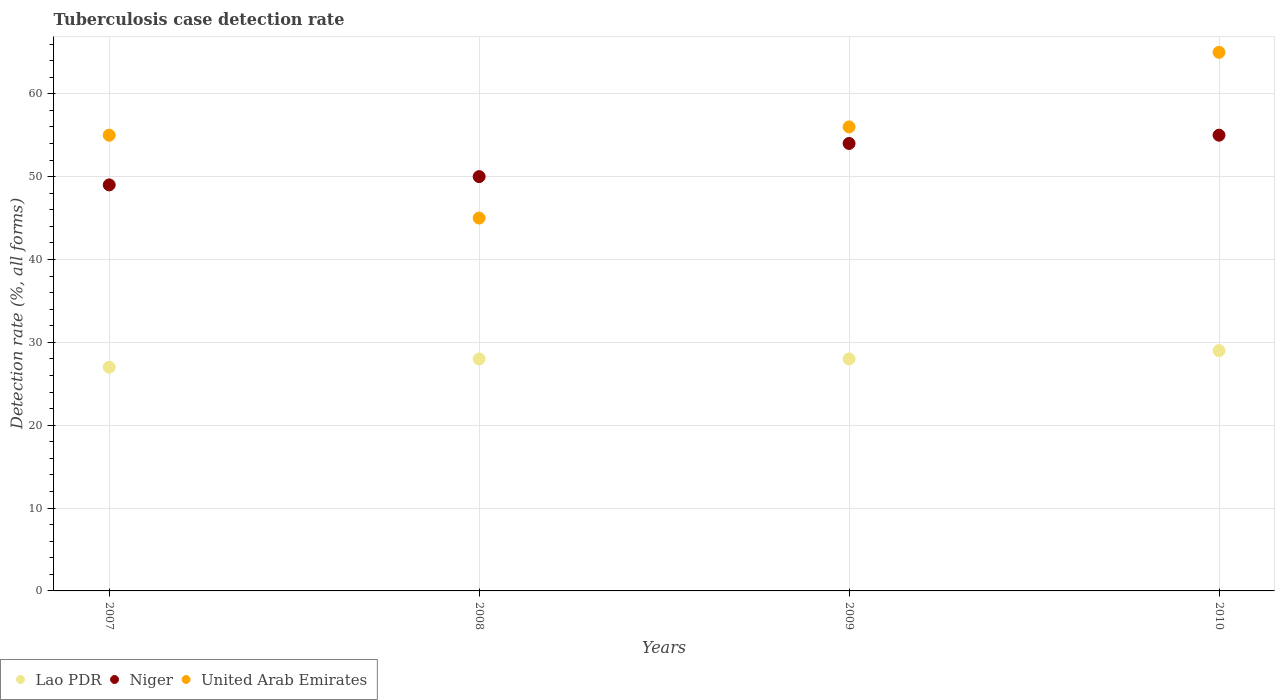What is the tuberculosis case detection rate in in Lao PDR in 2009?
Give a very brief answer. 28. Across all years, what is the maximum tuberculosis case detection rate in in Lao PDR?
Offer a terse response. 29. In which year was the tuberculosis case detection rate in in Niger minimum?
Give a very brief answer. 2007. What is the total tuberculosis case detection rate in in Lao PDR in the graph?
Ensure brevity in your answer.  112. In how many years, is the tuberculosis case detection rate in in United Arab Emirates greater than 42 %?
Offer a very short reply. 4. What is the ratio of the tuberculosis case detection rate in in Niger in 2007 to that in 2010?
Your answer should be very brief. 0.89. Is the tuberculosis case detection rate in in Lao PDR in 2008 less than that in 2009?
Your response must be concise. No. Is the sum of the tuberculosis case detection rate in in Niger in 2008 and 2009 greater than the maximum tuberculosis case detection rate in in Lao PDR across all years?
Ensure brevity in your answer.  Yes. Is it the case that in every year, the sum of the tuberculosis case detection rate in in Lao PDR and tuberculosis case detection rate in in Niger  is greater than the tuberculosis case detection rate in in United Arab Emirates?
Your response must be concise. Yes. Is the tuberculosis case detection rate in in United Arab Emirates strictly greater than the tuberculosis case detection rate in in Lao PDR over the years?
Your answer should be compact. Yes. Is the tuberculosis case detection rate in in Lao PDR strictly less than the tuberculosis case detection rate in in Niger over the years?
Give a very brief answer. Yes. How many dotlines are there?
Your response must be concise. 3. Are the values on the major ticks of Y-axis written in scientific E-notation?
Your answer should be compact. No. What is the title of the graph?
Give a very brief answer. Tuberculosis case detection rate. Does "Egypt, Arab Rep." appear as one of the legend labels in the graph?
Your answer should be very brief. No. What is the label or title of the Y-axis?
Your answer should be compact. Detection rate (%, all forms). What is the Detection rate (%, all forms) of Niger in 2007?
Your answer should be compact. 49. What is the Detection rate (%, all forms) of United Arab Emirates in 2007?
Keep it short and to the point. 55. What is the Detection rate (%, all forms) in Lao PDR in 2008?
Your answer should be very brief. 28. What is the Detection rate (%, all forms) of United Arab Emirates in 2008?
Your answer should be compact. 45. What is the Detection rate (%, all forms) of Niger in 2010?
Your answer should be very brief. 55. What is the Detection rate (%, all forms) in United Arab Emirates in 2010?
Offer a very short reply. 65. Across all years, what is the maximum Detection rate (%, all forms) in United Arab Emirates?
Offer a terse response. 65. What is the total Detection rate (%, all forms) in Lao PDR in the graph?
Give a very brief answer. 112. What is the total Detection rate (%, all forms) in Niger in the graph?
Offer a very short reply. 208. What is the total Detection rate (%, all forms) in United Arab Emirates in the graph?
Give a very brief answer. 221. What is the difference between the Detection rate (%, all forms) in Niger in 2007 and that in 2008?
Offer a terse response. -1. What is the difference between the Detection rate (%, all forms) in Lao PDR in 2007 and that in 2009?
Give a very brief answer. -1. What is the difference between the Detection rate (%, all forms) of United Arab Emirates in 2007 and that in 2009?
Keep it short and to the point. -1. What is the difference between the Detection rate (%, all forms) of United Arab Emirates in 2007 and that in 2010?
Make the answer very short. -10. What is the difference between the Detection rate (%, all forms) in Niger in 2008 and that in 2009?
Give a very brief answer. -4. What is the difference between the Detection rate (%, all forms) in Niger in 2008 and that in 2010?
Give a very brief answer. -5. What is the difference between the Detection rate (%, all forms) in United Arab Emirates in 2008 and that in 2010?
Your answer should be compact. -20. What is the difference between the Detection rate (%, all forms) in Lao PDR in 2009 and that in 2010?
Provide a succinct answer. -1. What is the difference between the Detection rate (%, all forms) of Lao PDR in 2007 and the Detection rate (%, all forms) of Niger in 2008?
Provide a succinct answer. -23. What is the difference between the Detection rate (%, all forms) of Lao PDR in 2007 and the Detection rate (%, all forms) of Niger in 2009?
Provide a succinct answer. -27. What is the difference between the Detection rate (%, all forms) in Niger in 2007 and the Detection rate (%, all forms) in United Arab Emirates in 2009?
Your answer should be compact. -7. What is the difference between the Detection rate (%, all forms) in Lao PDR in 2007 and the Detection rate (%, all forms) in United Arab Emirates in 2010?
Provide a short and direct response. -38. What is the difference between the Detection rate (%, all forms) in Niger in 2007 and the Detection rate (%, all forms) in United Arab Emirates in 2010?
Keep it short and to the point. -16. What is the difference between the Detection rate (%, all forms) of Lao PDR in 2008 and the Detection rate (%, all forms) of Niger in 2009?
Offer a very short reply. -26. What is the difference between the Detection rate (%, all forms) of Lao PDR in 2008 and the Detection rate (%, all forms) of United Arab Emirates in 2009?
Your answer should be very brief. -28. What is the difference between the Detection rate (%, all forms) of Niger in 2008 and the Detection rate (%, all forms) of United Arab Emirates in 2009?
Provide a short and direct response. -6. What is the difference between the Detection rate (%, all forms) of Lao PDR in 2008 and the Detection rate (%, all forms) of Niger in 2010?
Offer a terse response. -27. What is the difference between the Detection rate (%, all forms) in Lao PDR in 2008 and the Detection rate (%, all forms) in United Arab Emirates in 2010?
Keep it short and to the point. -37. What is the difference between the Detection rate (%, all forms) in Lao PDR in 2009 and the Detection rate (%, all forms) in United Arab Emirates in 2010?
Give a very brief answer. -37. What is the average Detection rate (%, all forms) of United Arab Emirates per year?
Give a very brief answer. 55.25. In the year 2007, what is the difference between the Detection rate (%, all forms) in Lao PDR and Detection rate (%, all forms) in United Arab Emirates?
Keep it short and to the point. -28. In the year 2007, what is the difference between the Detection rate (%, all forms) of Niger and Detection rate (%, all forms) of United Arab Emirates?
Provide a succinct answer. -6. In the year 2008, what is the difference between the Detection rate (%, all forms) of Lao PDR and Detection rate (%, all forms) of Niger?
Give a very brief answer. -22. In the year 2008, what is the difference between the Detection rate (%, all forms) in Niger and Detection rate (%, all forms) in United Arab Emirates?
Ensure brevity in your answer.  5. In the year 2009, what is the difference between the Detection rate (%, all forms) of Lao PDR and Detection rate (%, all forms) of United Arab Emirates?
Provide a succinct answer. -28. In the year 2009, what is the difference between the Detection rate (%, all forms) in Niger and Detection rate (%, all forms) in United Arab Emirates?
Keep it short and to the point. -2. In the year 2010, what is the difference between the Detection rate (%, all forms) in Lao PDR and Detection rate (%, all forms) in United Arab Emirates?
Ensure brevity in your answer.  -36. What is the ratio of the Detection rate (%, all forms) in Lao PDR in 2007 to that in 2008?
Your response must be concise. 0.96. What is the ratio of the Detection rate (%, all forms) of United Arab Emirates in 2007 to that in 2008?
Offer a very short reply. 1.22. What is the ratio of the Detection rate (%, all forms) of Niger in 2007 to that in 2009?
Your answer should be compact. 0.91. What is the ratio of the Detection rate (%, all forms) in United Arab Emirates in 2007 to that in 2009?
Give a very brief answer. 0.98. What is the ratio of the Detection rate (%, all forms) of Lao PDR in 2007 to that in 2010?
Your answer should be very brief. 0.93. What is the ratio of the Detection rate (%, all forms) in Niger in 2007 to that in 2010?
Provide a succinct answer. 0.89. What is the ratio of the Detection rate (%, all forms) of United Arab Emirates in 2007 to that in 2010?
Offer a very short reply. 0.85. What is the ratio of the Detection rate (%, all forms) in Lao PDR in 2008 to that in 2009?
Your answer should be very brief. 1. What is the ratio of the Detection rate (%, all forms) in Niger in 2008 to that in 2009?
Give a very brief answer. 0.93. What is the ratio of the Detection rate (%, all forms) of United Arab Emirates in 2008 to that in 2009?
Give a very brief answer. 0.8. What is the ratio of the Detection rate (%, all forms) in Lao PDR in 2008 to that in 2010?
Provide a short and direct response. 0.97. What is the ratio of the Detection rate (%, all forms) of Niger in 2008 to that in 2010?
Provide a succinct answer. 0.91. What is the ratio of the Detection rate (%, all forms) of United Arab Emirates in 2008 to that in 2010?
Your answer should be very brief. 0.69. What is the ratio of the Detection rate (%, all forms) in Lao PDR in 2009 to that in 2010?
Your response must be concise. 0.97. What is the ratio of the Detection rate (%, all forms) of Niger in 2009 to that in 2010?
Your answer should be very brief. 0.98. What is the ratio of the Detection rate (%, all forms) in United Arab Emirates in 2009 to that in 2010?
Make the answer very short. 0.86. What is the difference between the highest and the second highest Detection rate (%, all forms) of Lao PDR?
Offer a terse response. 1. What is the difference between the highest and the lowest Detection rate (%, all forms) in Niger?
Make the answer very short. 6. 